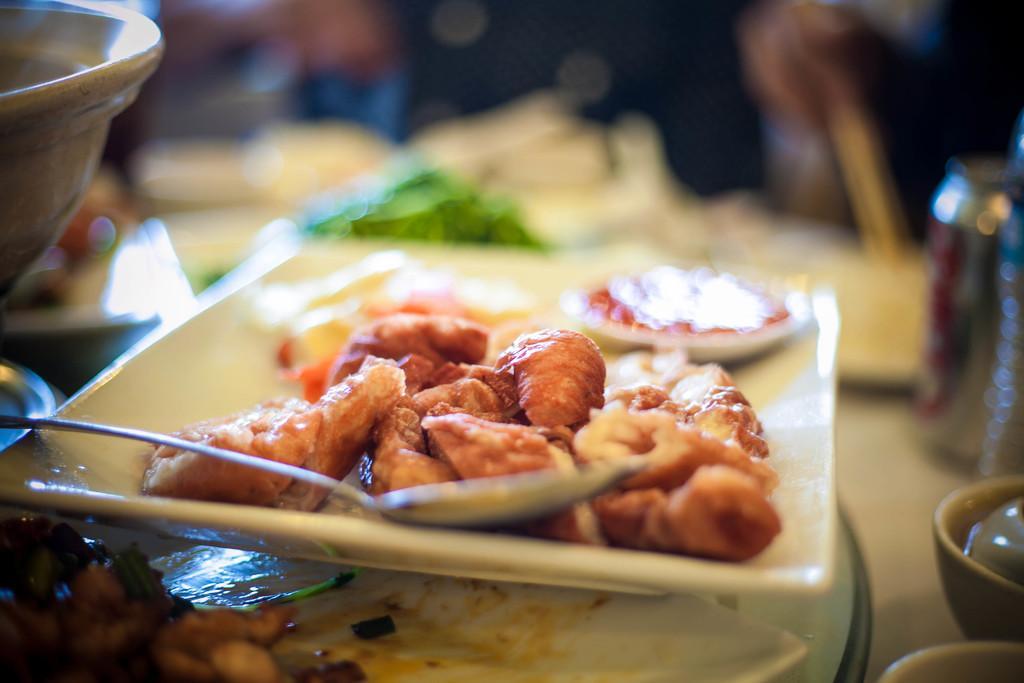Please provide a concise description of this image. In this image we can see food and spoon on plate placed on the table. On the right side of the image we can see bowls and tin. 